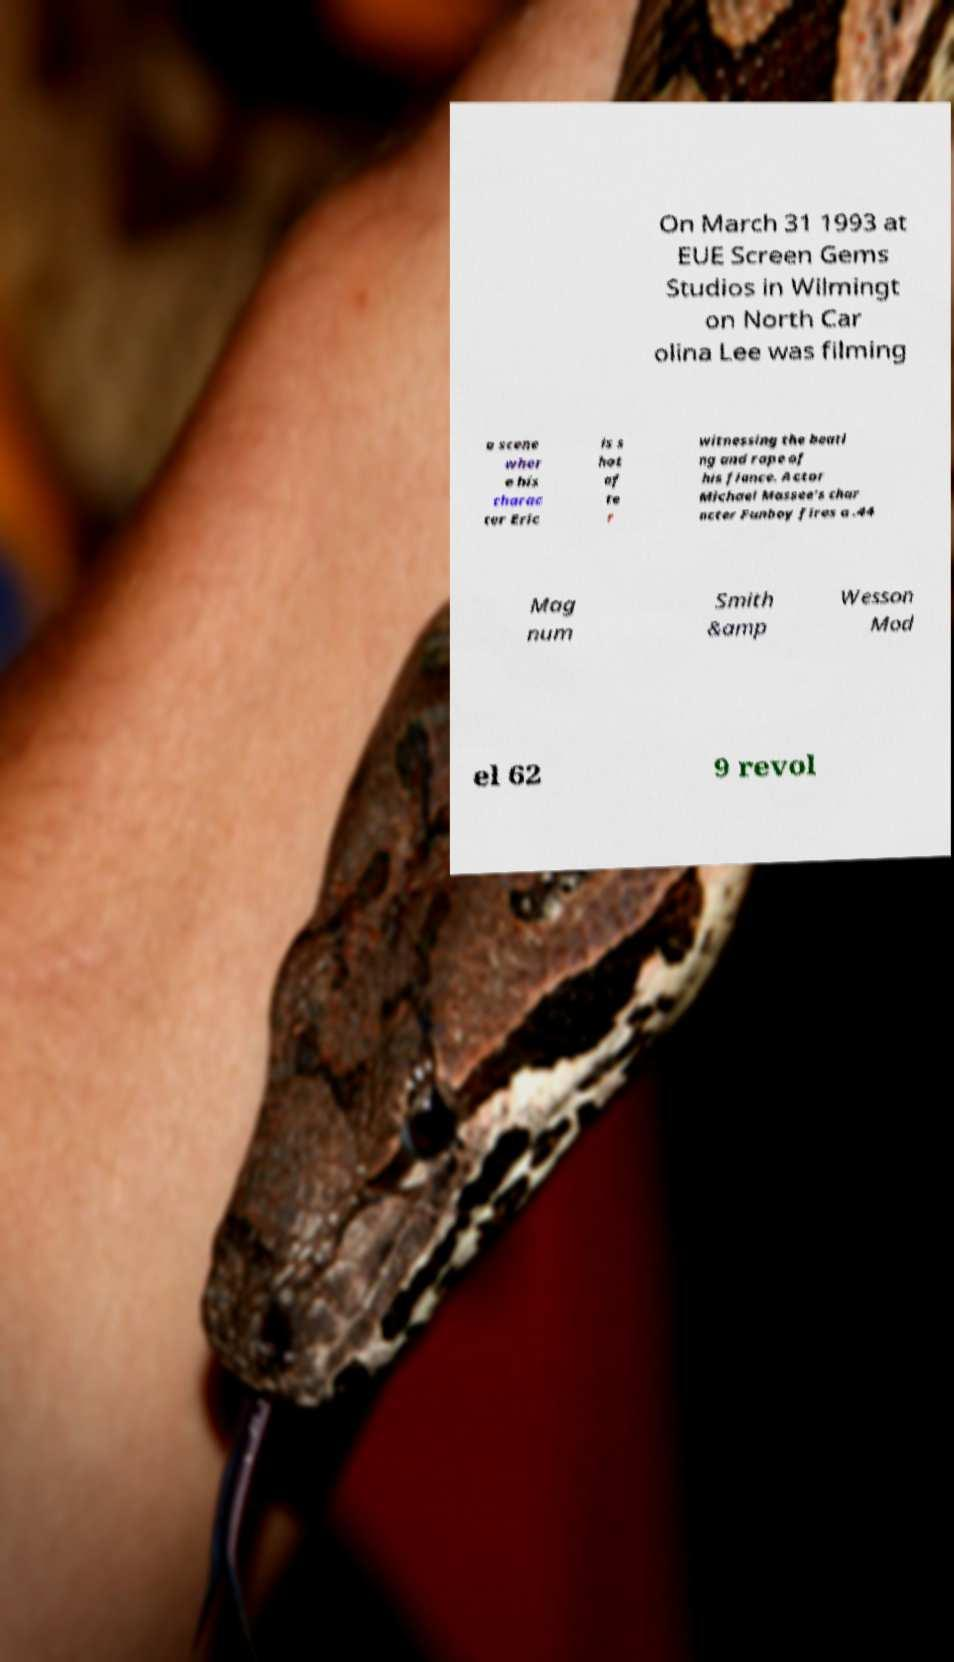Please read and relay the text visible in this image. What does it say? On March 31 1993 at EUE Screen Gems Studios in Wilmingt on North Car olina Lee was filming a scene wher e his charac ter Eric is s hot af te r witnessing the beati ng and rape of his fiance. Actor Michael Massee's char acter Funboy fires a .44 Mag num Smith &amp Wesson Mod el 62 9 revol 